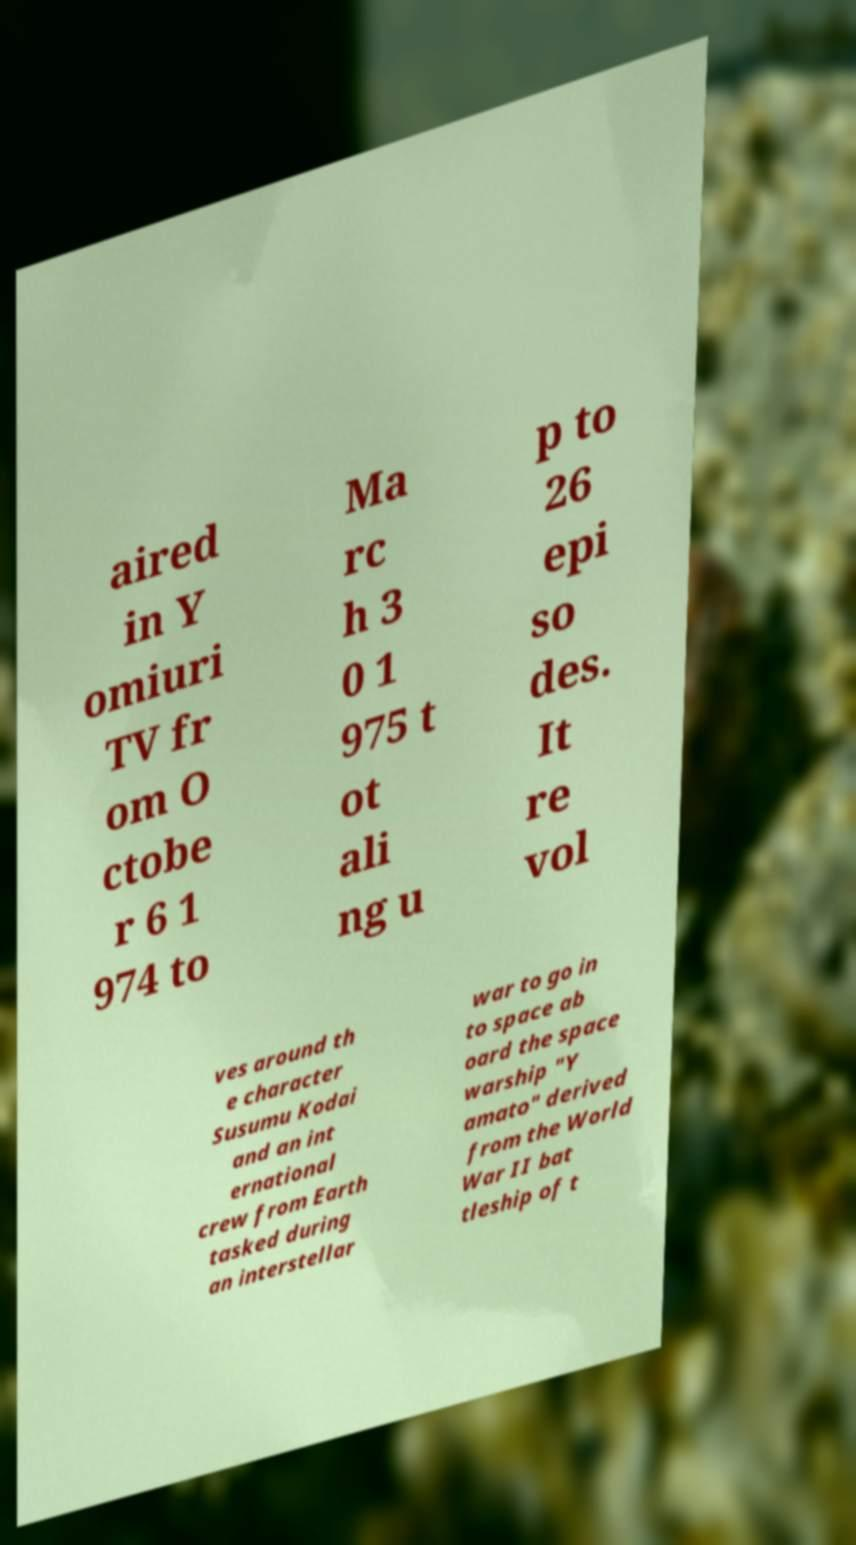Please identify and transcribe the text found in this image. aired in Y omiuri TV fr om O ctobe r 6 1 974 to Ma rc h 3 0 1 975 t ot ali ng u p to 26 epi so des. It re vol ves around th e character Susumu Kodai and an int ernational crew from Earth tasked during an interstellar war to go in to space ab oard the space warship "Y amato" derived from the World War II bat tleship of t 